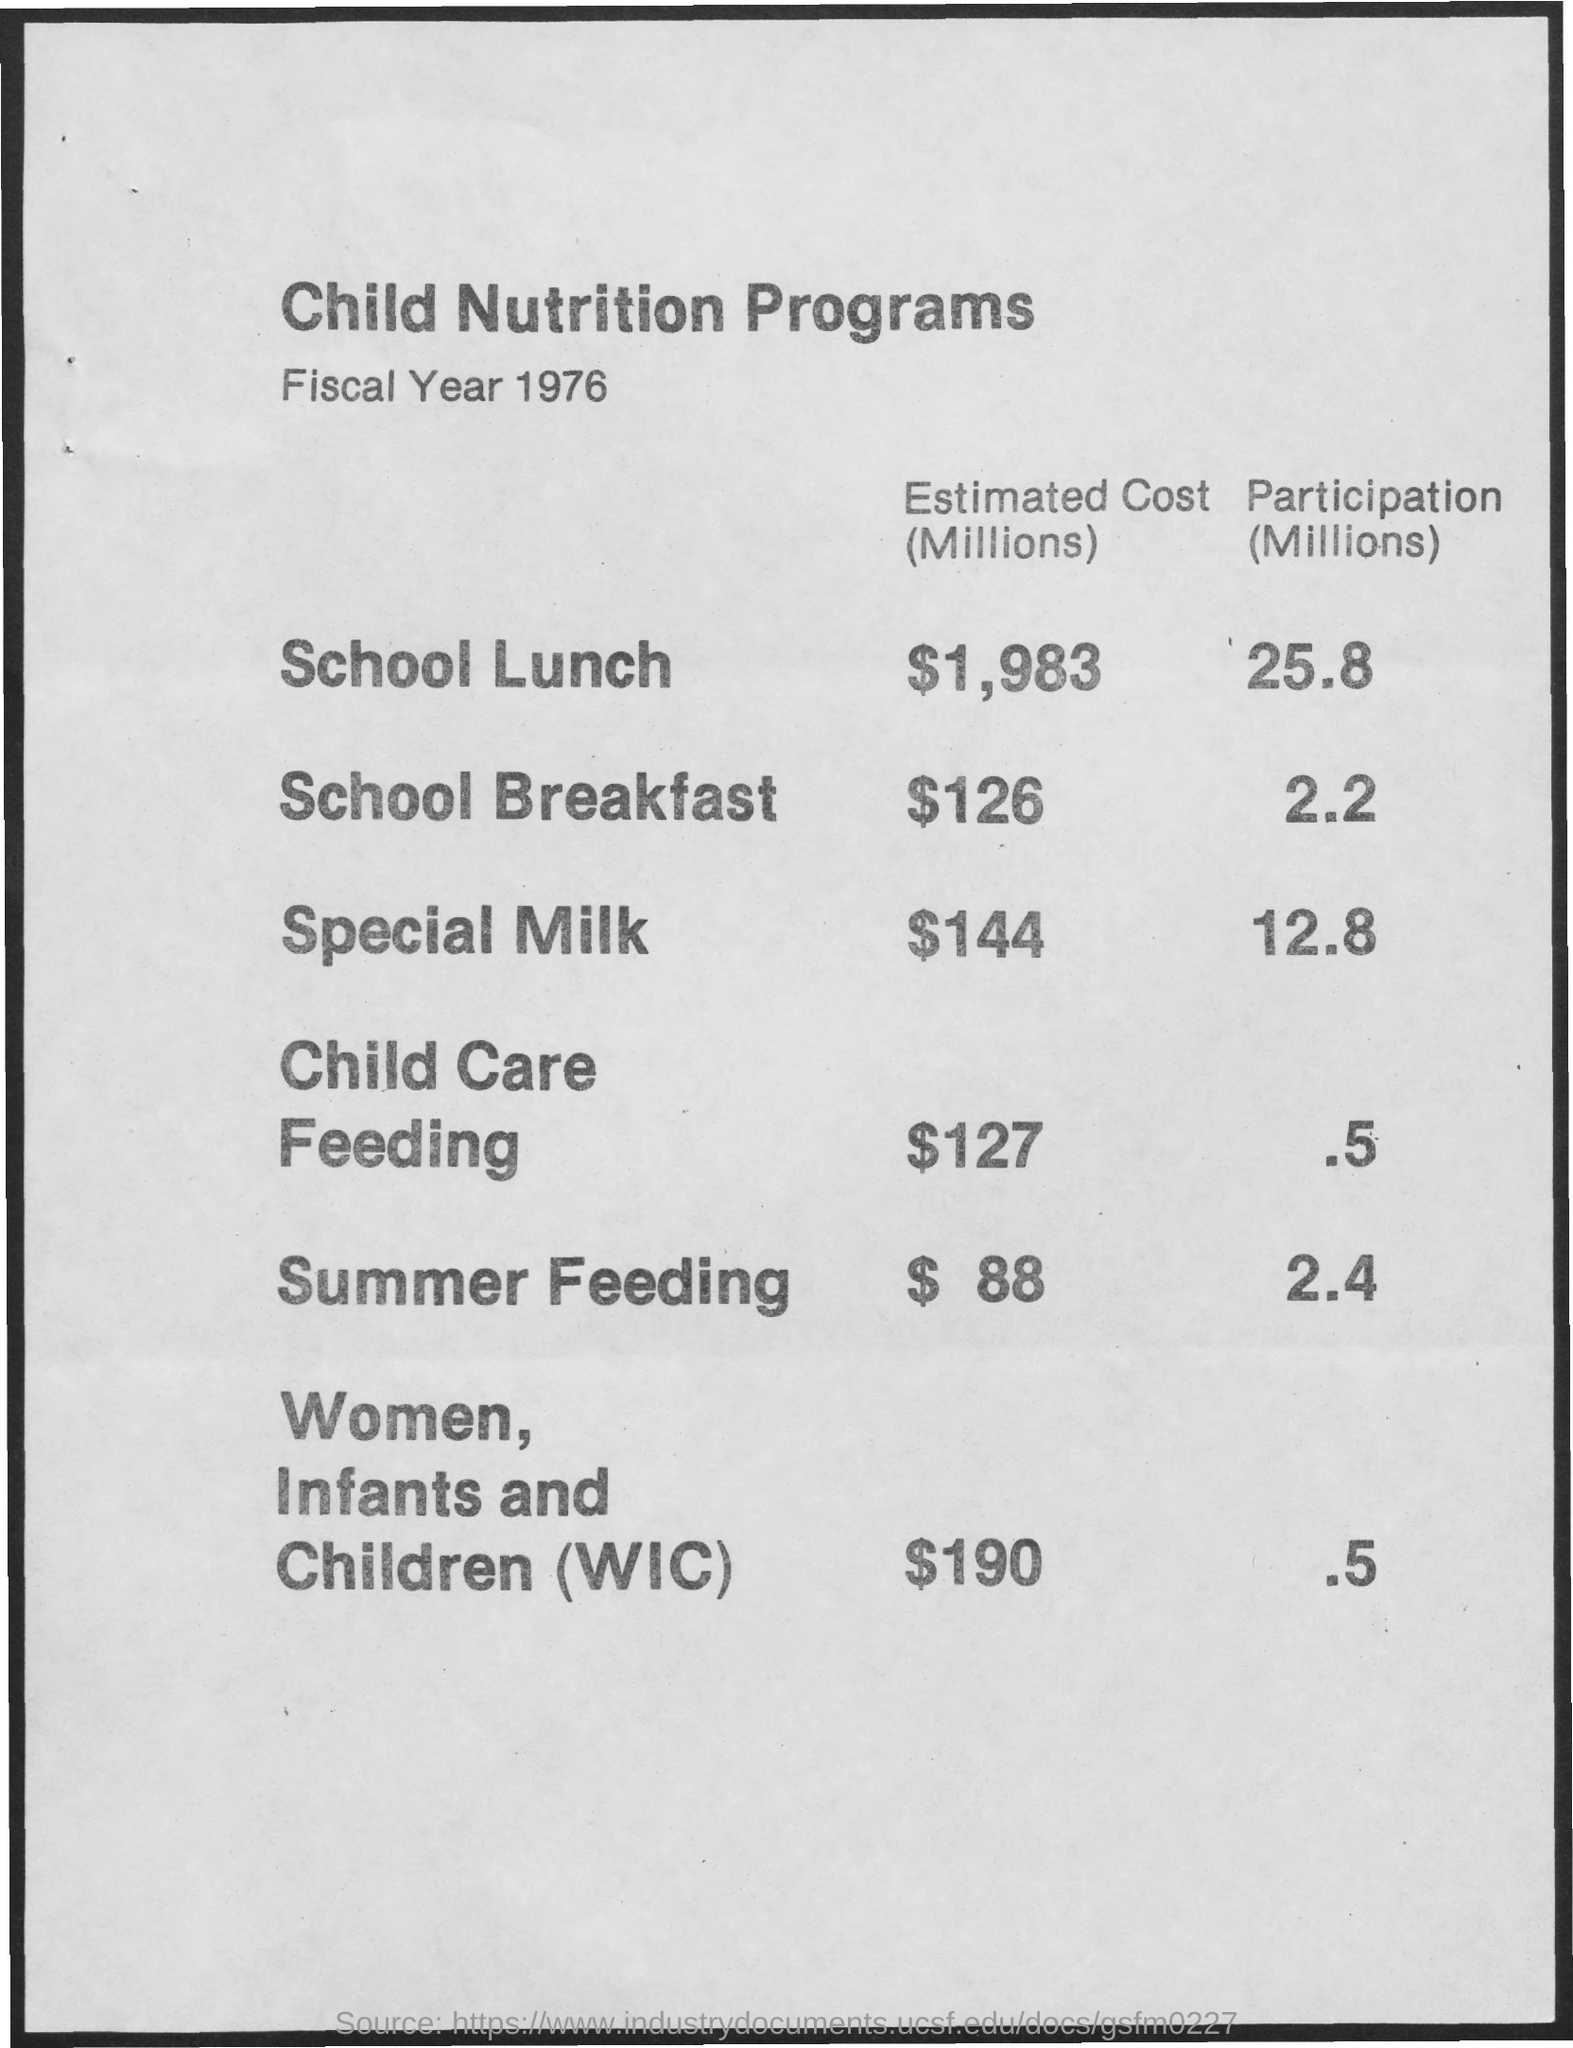What is the Title of the document?
Your answer should be very brief. Child Nutrition Programs. What is the Estimated Cost (Millions) for School Lunch?
Provide a succinct answer. $1,983. What is the Estimated Cost (Millions) for School Breakfast?
Ensure brevity in your answer.  $126. What is the Estimated Cost (Millions) for Special Milk?
Give a very brief answer. $144. What is the Estimated Cost (Millions) for Child Care Feeding?
Offer a terse response. $127. What is the Estimated Cost (Millions) for Summer Feeding?
Keep it short and to the point. $ 88. What is the Estimated Cost (Millions) for Women, Infants and Children (WIC)?
Offer a very short reply. $190. What is the Participation (Millions) for School Lunch?
Make the answer very short. 25.8. What is the Participation (Millions) for School Breakfast?
Your answer should be very brief. 2.2. 